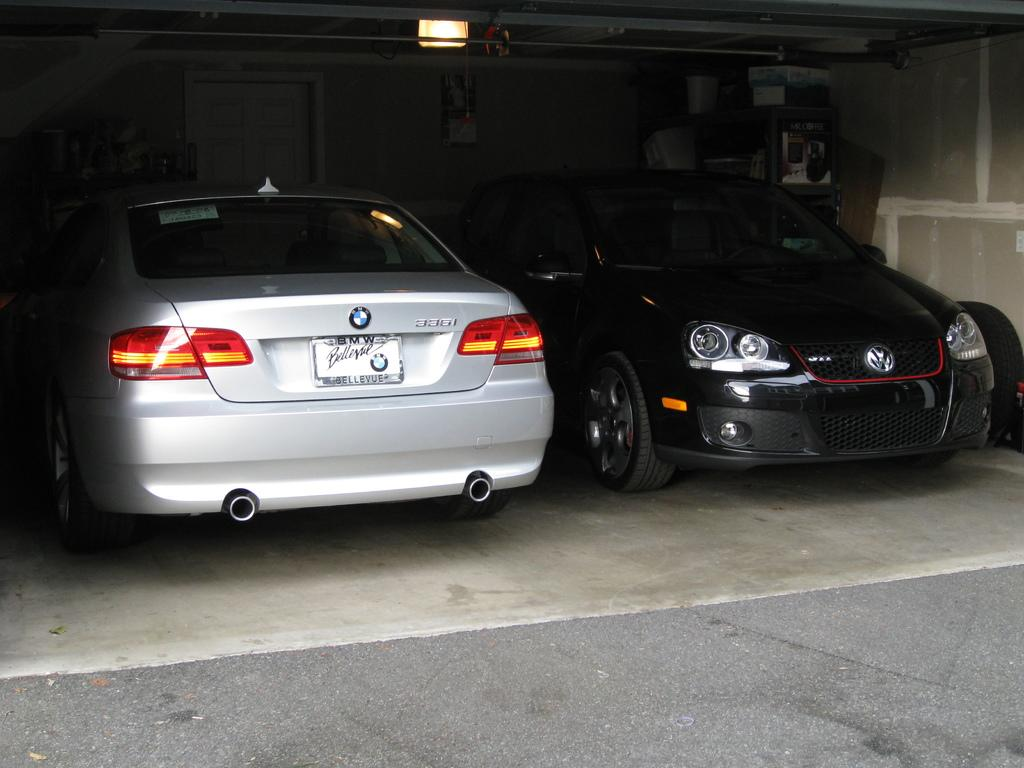What type of vehicles are on the ground in the image? There are cars on the ground in the image. What colors are the cars? The cars are black and white in color. What can be seen in the background of the image? There is light visible in the background of the image, along with other objects. What hobbies do the cars have in the image? Cars do not have hobbies, as they are inanimate objects. 